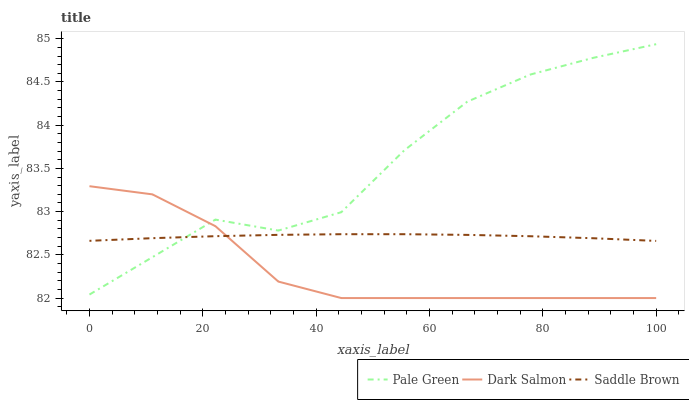Does Dark Salmon have the minimum area under the curve?
Answer yes or no. Yes. Does Pale Green have the maximum area under the curve?
Answer yes or no. Yes. Does Saddle Brown have the minimum area under the curve?
Answer yes or no. No. Does Saddle Brown have the maximum area under the curve?
Answer yes or no. No. Is Saddle Brown the smoothest?
Answer yes or no. Yes. Is Pale Green the roughest?
Answer yes or no. Yes. Is Dark Salmon the smoothest?
Answer yes or no. No. Is Dark Salmon the roughest?
Answer yes or no. No. Does Saddle Brown have the lowest value?
Answer yes or no. No. Does Pale Green have the highest value?
Answer yes or no. Yes. Does Dark Salmon have the highest value?
Answer yes or no. No. Does Dark Salmon intersect Saddle Brown?
Answer yes or no. Yes. Is Dark Salmon less than Saddle Brown?
Answer yes or no. No. Is Dark Salmon greater than Saddle Brown?
Answer yes or no. No. 